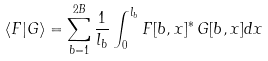<formula> <loc_0><loc_0><loc_500><loc_500>\langle F | G \rangle = \sum _ { b = 1 } ^ { 2 B } \frac { 1 } { l _ { b } } \int _ { 0 } ^ { l _ { b } } F [ b , x ] ^ { * } \, G [ b , x ] d x</formula> 